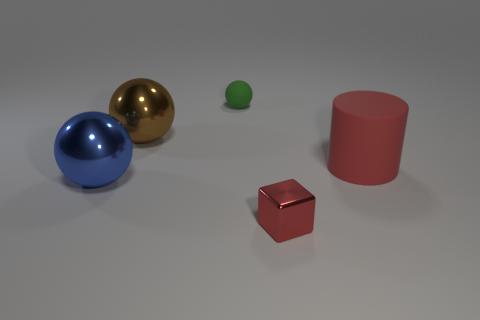There is a cylinder that is the same color as the small block; what size is it?
Give a very brief answer. Large. The big rubber object that is the same color as the tiny shiny block is what shape?
Offer a terse response. Cylinder. How many other objects are there of the same size as the red block?
Provide a succinct answer. 1. What size is the blue ball?
Give a very brief answer. Large. Is the green ball made of the same material as the big thing that is right of the brown shiny ball?
Your answer should be very brief. Yes. Are there any other small red objects of the same shape as the small metal thing?
Provide a short and direct response. No. What is the material of the red object that is the same size as the green matte ball?
Your response must be concise. Metal. There is a red cube right of the small green matte thing; how big is it?
Make the answer very short. Small. There is a matte thing that is to the left of the red cube; does it have the same size as the red object that is right of the small shiny block?
Your response must be concise. No. How many large blue things are made of the same material as the large red cylinder?
Offer a terse response. 0. 